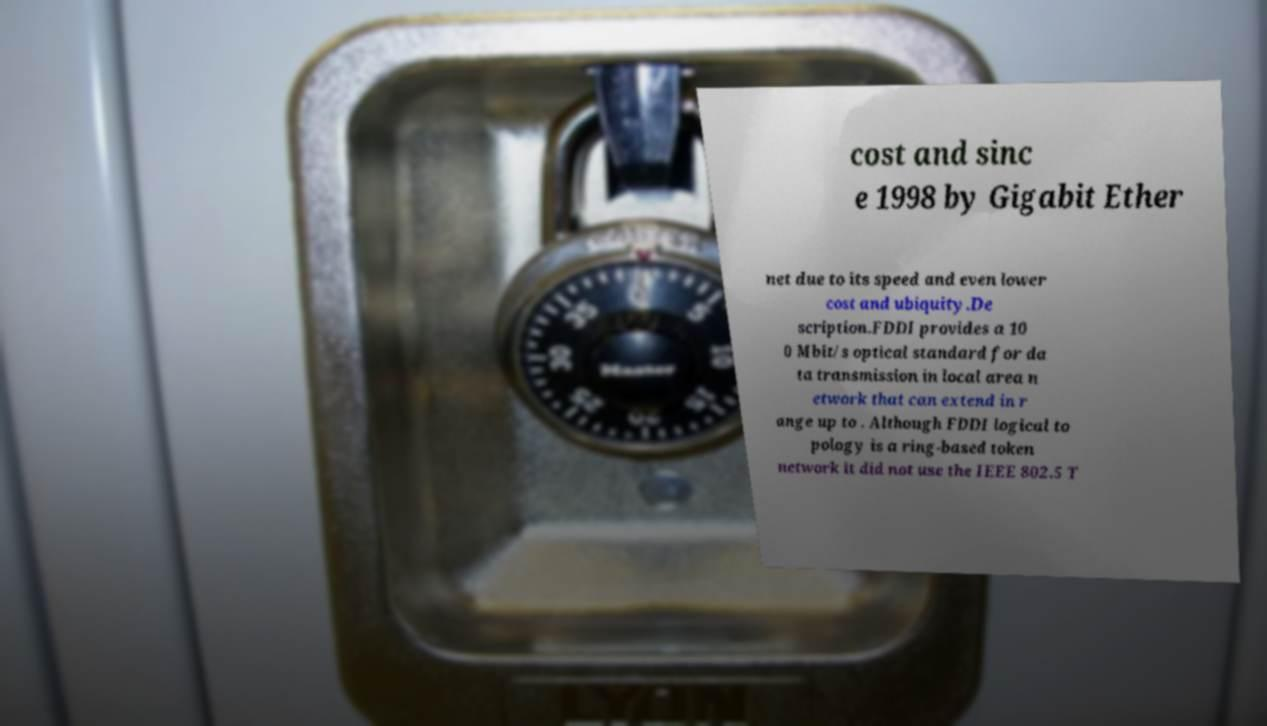Can you accurately transcribe the text from the provided image for me? cost and sinc e 1998 by Gigabit Ether net due to its speed and even lower cost and ubiquity.De scription.FDDI provides a 10 0 Mbit/s optical standard for da ta transmission in local area n etwork that can extend in r ange up to . Although FDDI logical to pology is a ring-based token network it did not use the IEEE 802.5 T 